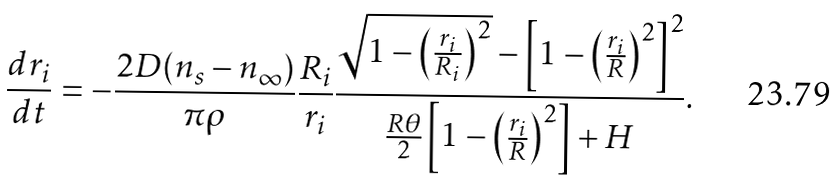Convert formula to latex. <formula><loc_0><loc_0><loc_500><loc_500>\frac { d r _ { i } } { d t } = - \frac { 2 D ( n _ { s } - n _ { \infty } ) } { \pi \rho } \frac { R _ { i } } { r _ { i } } \frac { \sqrt { 1 - \left ( \frac { r _ { i } } { R _ { i } } \right ) ^ { 2 } } - \left [ 1 - \left ( \frac { r _ { i } } R \right ) ^ { 2 } \right ] ^ { 2 } } { \frac { R \theta } 2 \left [ 1 - \left ( \frac { r _ { i } } R \right ) ^ { 2 } \right ] + H } .</formula> 